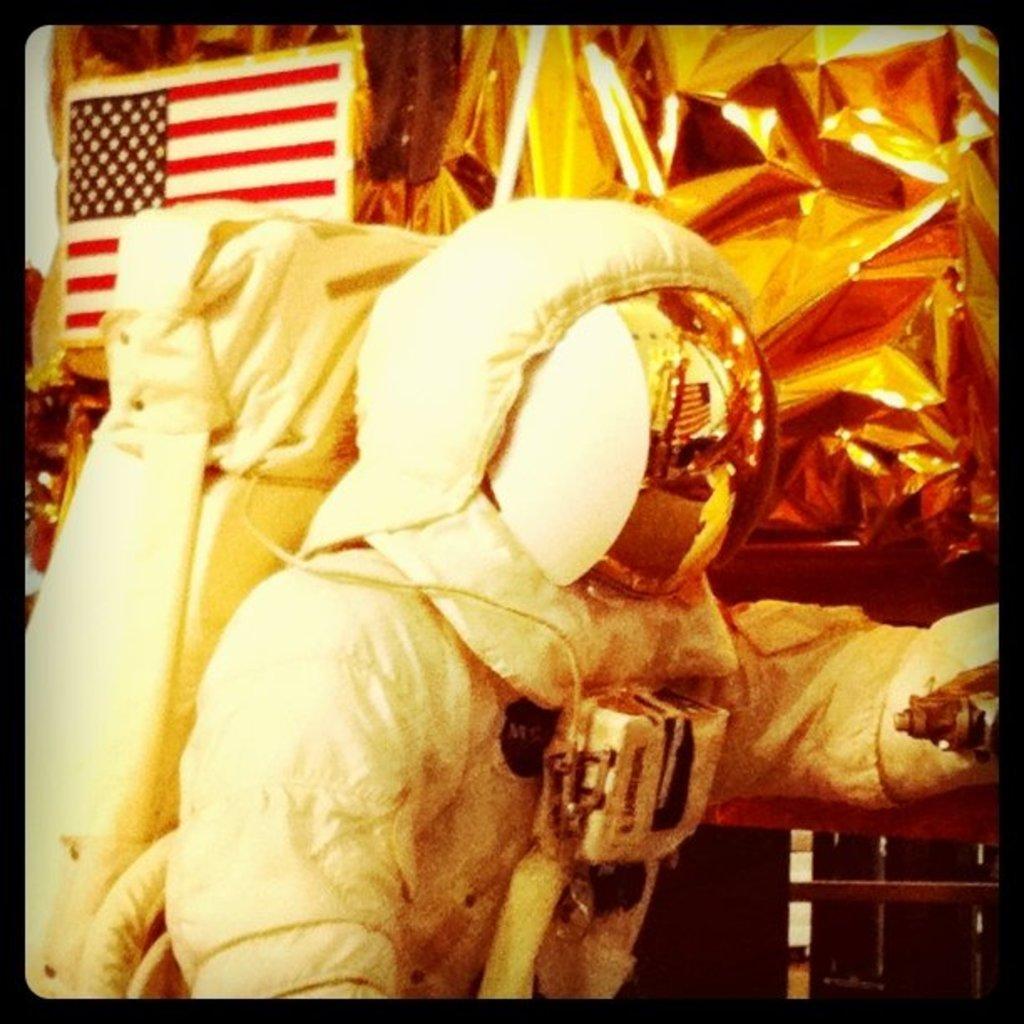In one or two sentences, can you explain what this image depicts? In this image in the center there is one person who is wearing a costume, and in the background there are covers, flag and some objects. 